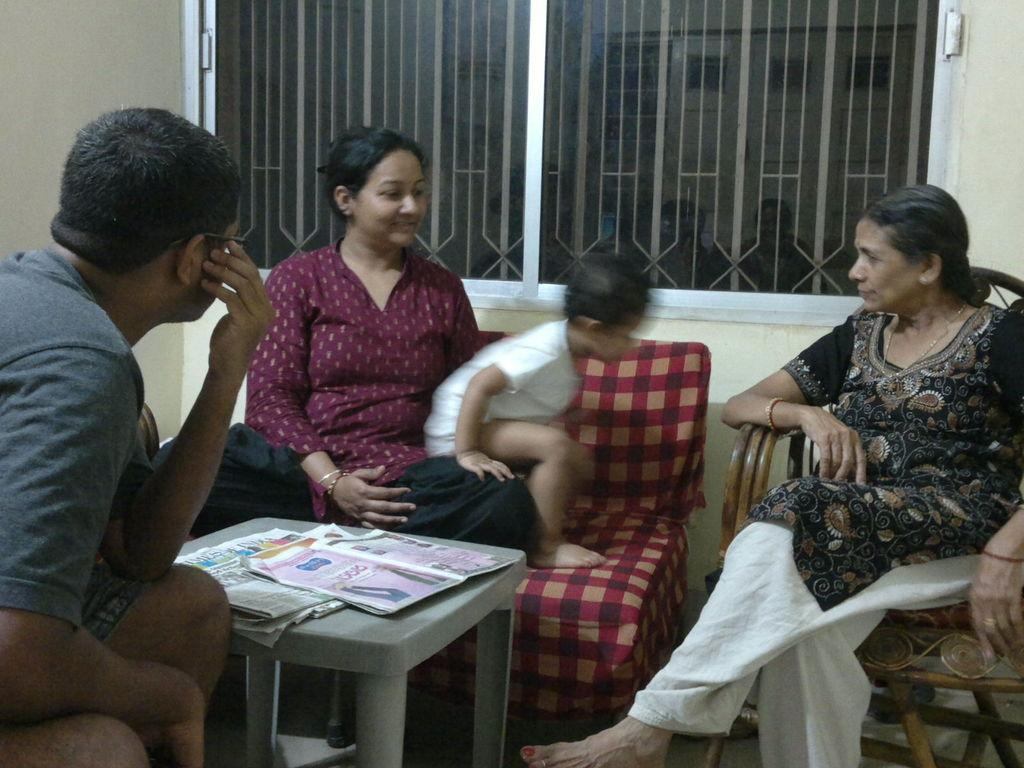How many people are present in the image? There are four persons in the image. What is located in the middle of the image? There is a table in the middle of the image. What is placed on the table? There are newspapers on the table. What can be seen at the back of the image? There is a window at the back of the image. What type of railway can be seen in the image? There is no railway present in the image. Is there a volleyball game happening in the image? There is no volleyball game or any reference to volleyball in the image. 